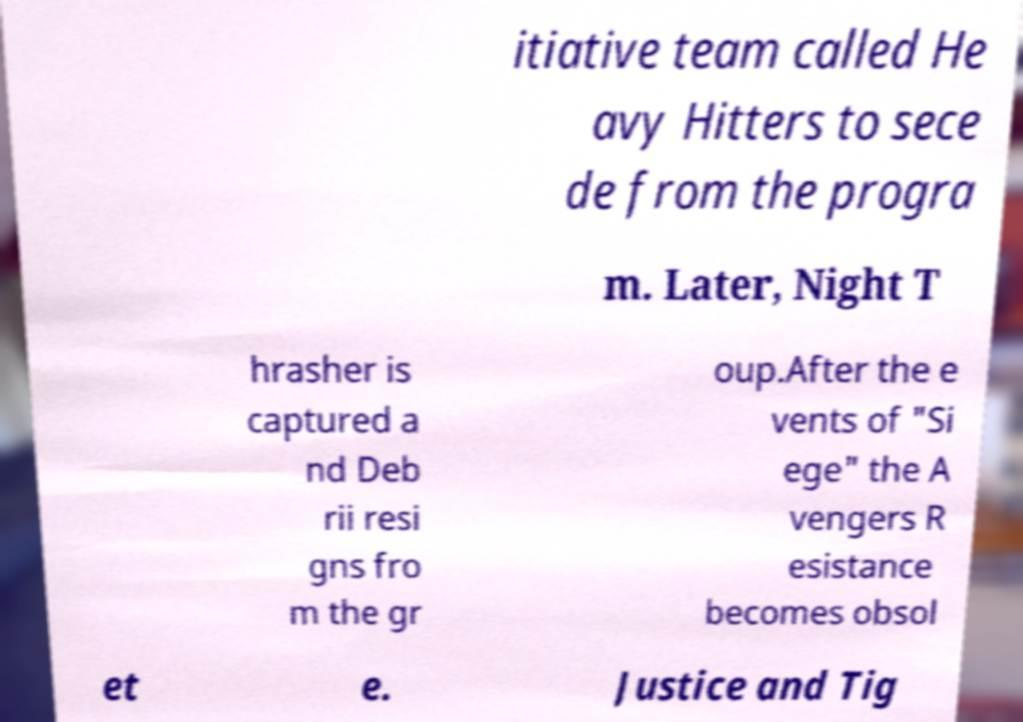What messages or text are displayed in this image? I need them in a readable, typed format. itiative team called He avy Hitters to sece de from the progra m. Later, Night T hrasher is captured a nd Deb rii resi gns fro m the gr oup.After the e vents of "Si ege" the A vengers R esistance becomes obsol et e. Justice and Tig 